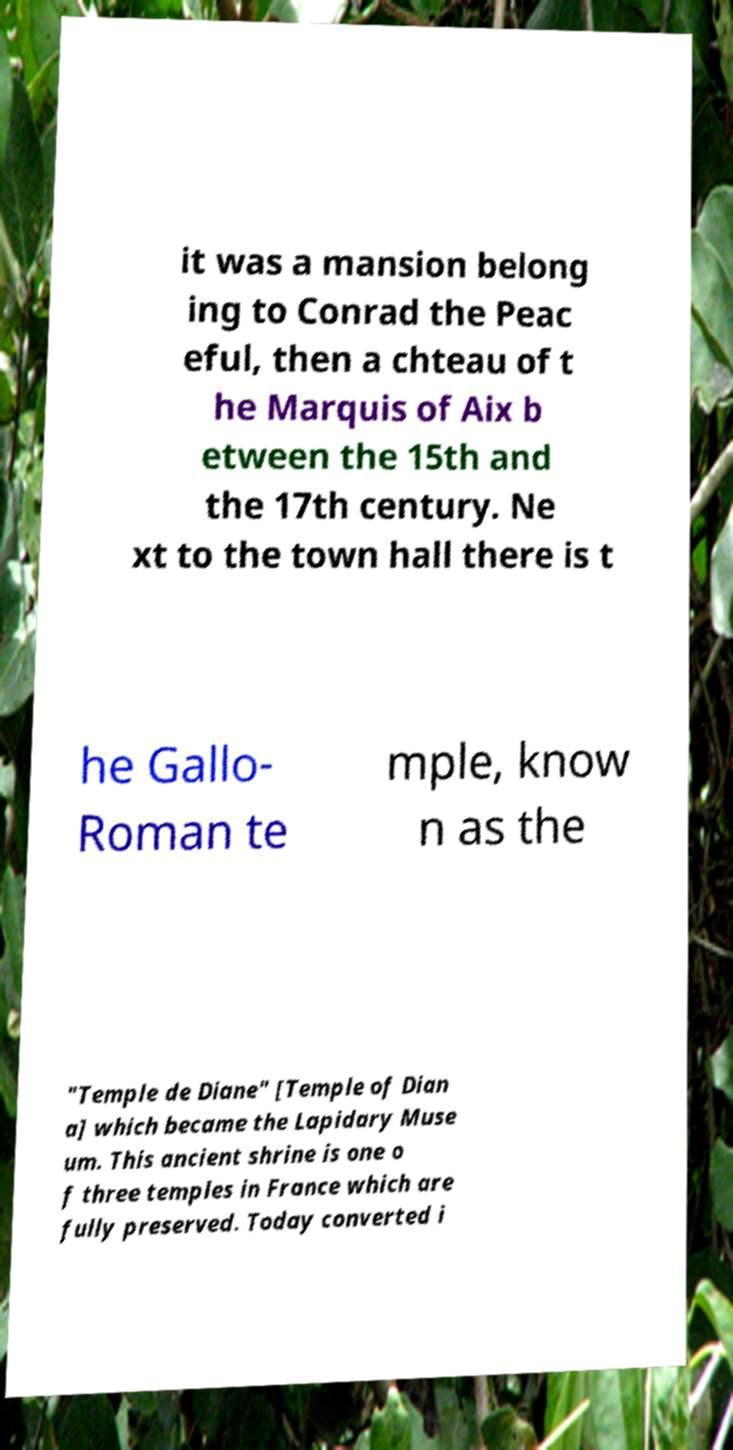There's text embedded in this image that I need extracted. Can you transcribe it verbatim? it was a mansion belong ing to Conrad the Peac eful, then a chteau of t he Marquis of Aix b etween the 15th and the 17th century. Ne xt to the town hall there is t he Gallo- Roman te mple, know n as the "Temple de Diane" [Temple of Dian a] which became the Lapidary Muse um. This ancient shrine is one o f three temples in France which are fully preserved. Today converted i 